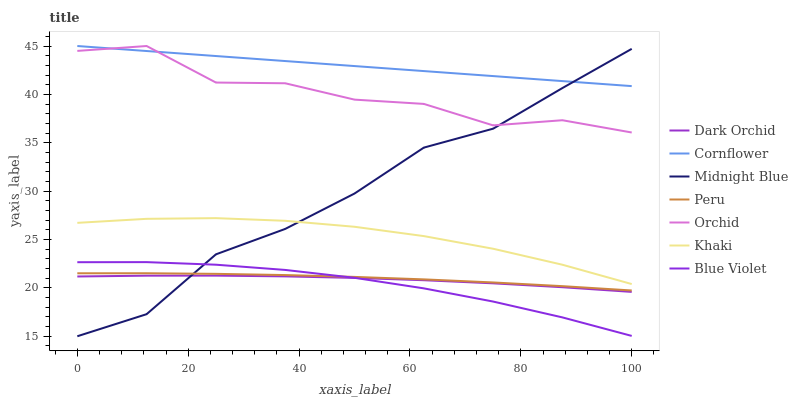Does Blue Violet have the minimum area under the curve?
Answer yes or no. Yes. Does Cornflower have the maximum area under the curve?
Answer yes or no. Yes. Does Khaki have the minimum area under the curve?
Answer yes or no. No. Does Khaki have the maximum area under the curve?
Answer yes or no. No. Is Cornflower the smoothest?
Answer yes or no. Yes. Is Orchid the roughest?
Answer yes or no. Yes. Is Khaki the smoothest?
Answer yes or no. No. Is Khaki the roughest?
Answer yes or no. No. Does Midnight Blue have the lowest value?
Answer yes or no. Yes. Does Khaki have the lowest value?
Answer yes or no. No. Does Orchid have the highest value?
Answer yes or no. Yes. Does Khaki have the highest value?
Answer yes or no. No. Is Peru less than Khaki?
Answer yes or no. Yes. Is Orchid greater than Blue Violet?
Answer yes or no. Yes. Does Dark Orchid intersect Blue Violet?
Answer yes or no. Yes. Is Dark Orchid less than Blue Violet?
Answer yes or no. No. Is Dark Orchid greater than Blue Violet?
Answer yes or no. No. Does Peru intersect Khaki?
Answer yes or no. No. 